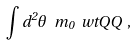<formula> <loc_0><loc_0><loc_500><loc_500>\int d ^ { 2 } \theta \ m _ { 0 } { \ w t Q Q } \ ,</formula> 